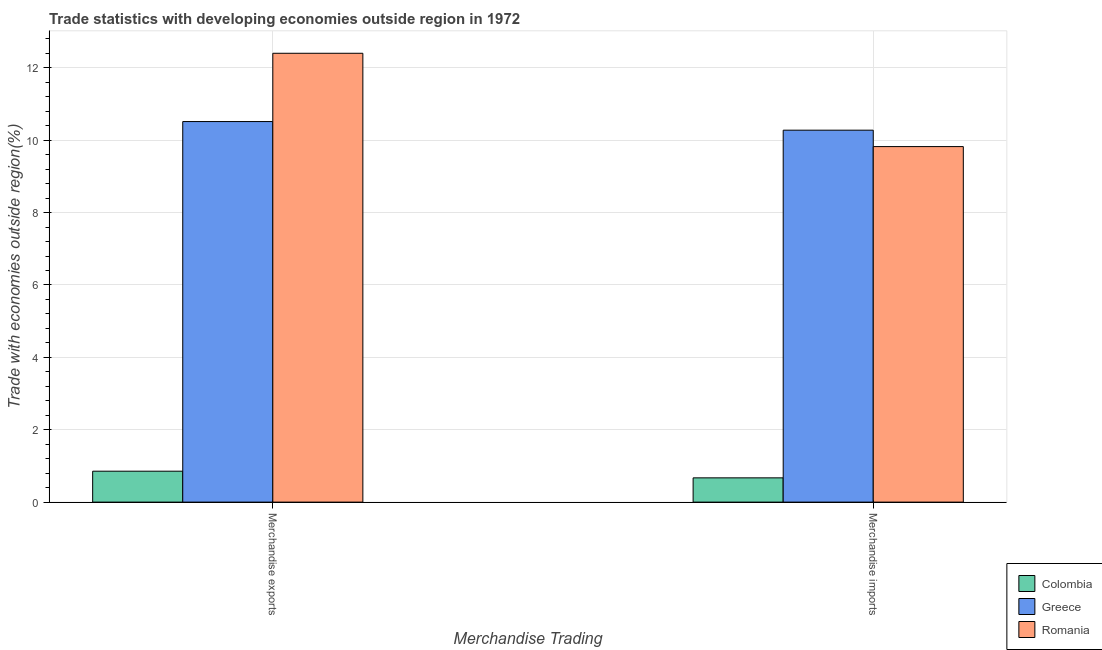Are the number of bars per tick equal to the number of legend labels?
Provide a short and direct response. Yes. How many bars are there on the 1st tick from the left?
Offer a very short reply. 3. How many bars are there on the 2nd tick from the right?
Ensure brevity in your answer.  3. What is the merchandise exports in Greece?
Your answer should be very brief. 10.52. Across all countries, what is the maximum merchandise imports?
Provide a short and direct response. 10.28. Across all countries, what is the minimum merchandise exports?
Provide a short and direct response. 0.85. In which country was the merchandise exports maximum?
Your response must be concise. Romania. What is the total merchandise imports in the graph?
Offer a very short reply. 20.77. What is the difference between the merchandise imports in Romania and that in Colombia?
Keep it short and to the point. 9.15. What is the difference between the merchandise exports in Colombia and the merchandise imports in Greece?
Provide a short and direct response. -9.42. What is the average merchandise imports per country?
Your answer should be compact. 6.92. What is the difference between the merchandise exports and merchandise imports in Greece?
Ensure brevity in your answer.  0.24. In how many countries, is the merchandise exports greater than 11.6 %?
Provide a short and direct response. 1. What is the ratio of the merchandise exports in Colombia to that in Greece?
Provide a succinct answer. 0.08. What does the 2nd bar from the left in Merchandise imports represents?
Offer a terse response. Greece. What does the 1st bar from the right in Merchandise exports represents?
Provide a short and direct response. Romania. How many bars are there?
Your answer should be compact. 6. Are the values on the major ticks of Y-axis written in scientific E-notation?
Keep it short and to the point. No. Where does the legend appear in the graph?
Make the answer very short. Bottom right. How are the legend labels stacked?
Give a very brief answer. Vertical. What is the title of the graph?
Your answer should be compact. Trade statistics with developing economies outside region in 1972. Does "Luxembourg" appear as one of the legend labels in the graph?
Keep it short and to the point. No. What is the label or title of the X-axis?
Ensure brevity in your answer.  Merchandise Trading. What is the label or title of the Y-axis?
Provide a succinct answer. Trade with economies outside region(%). What is the Trade with economies outside region(%) of Colombia in Merchandise exports?
Your response must be concise. 0.85. What is the Trade with economies outside region(%) in Greece in Merchandise exports?
Provide a short and direct response. 10.52. What is the Trade with economies outside region(%) in Romania in Merchandise exports?
Keep it short and to the point. 12.4. What is the Trade with economies outside region(%) in Colombia in Merchandise imports?
Your response must be concise. 0.67. What is the Trade with economies outside region(%) in Greece in Merchandise imports?
Ensure brevity in your answer.  10.28. What is the Trade with economies outside region(%) of Romania in Merchandise imports?
Offer a terse response. 9.82. Across all Merchandise Trading, what is the maximum Trade with economies outside region(%) in Colombia?
Your answer should be very brief. 0.85. Across all Merchandise Trading, what is the maximum Trade with economies outside region(%) of Greece?
Make the answer very short. 10.52. Across all Merchandise Trading, what is the maximum Trade with economies outside region(%) of Romania?
Ensure brevity in your answer.  12.4. Across all Merchandise Trading, what is the minimum Trade with economies outside region(%) of Colombia?
Make the answer very short. 0.67. Across all Merchandise Trading, what is the minimum Trade with economies outside region(%) of Greece?
Keep it short and to the point. 10.28. Across all Merchandise Trading, what is the minimum Trade with economies outside region(%) in Romania?
Your answer should be very brief. 9.82. What is the total Trade with economies outside region(%) in Colombia in the graph?
Ensure brevity in your answer.  1.53. What is the total Trade with economies outside region(%) in Greece in the graph?
Provide a short and direct response. 20.79. What is the total Trade with economies outside region(%) of Romania in the graph?
Offer a terse response. 22.23. What is the difference between the Trade with economies outside region(%) of Colombia in Merchandise exports and that in Merchandise imports?
Your answer should be compact. 0.18. What is the difference between the Trade with economies outside region(%) in Greece in Merchandise exports and that in Merchandise imports?
Your response must be concise. 0.24. What is the difference between the Trade with economies outside region(%) of Romania in Merchandise exports and that in Merchandise imports?
Your response must be concise. 2.58. What is the difference between the Trade with economies outside region(%) in Colombia in Merchandise exports and the Trade with economies outside region(%) in Greece in Merchandise imports?
Give a very brief answer. -9.42. What is the difference between the Trade with economies outside region(%) in Colombia in Merchandise exports and the Trade with economies outside region(%) in Romania in Merchandise imports?
Your answer should be compact. -8.97. What is the difference between the Trade with economies outside region(%) in Greece in Merchandise exports and the Trade with economies outside region(%) in Romania in Merchandise imports?
Provide a succinct answer. 0.69. What is the average Trade with economies outside region(%) of Colombia per Merchandise Trading?
Your response must be concise. 0.76. What is the average Trade with economies outside region(%) in Greece per Merchandise Trading?
Ensure brevity in your answer.  10.4. What is the average Trade with economies outside region(%) in Romania per Merchandise Trading?
Your answer should be very brief. 11.11. What is the difference between the Trade with economies outside region(%) of Colombia and Trade with economies outside region(%) of Greece in Merchandise exports?
Give a very brief answer. -9.66. What is the difference between the Trade with economies outside region(%) of Colombia and Trade with economies outside region(%) of Romania in Merchandise exports?
Provide a short and direct response. -11.55. What is the difference between the Trade with economies outside region(%) of Greece and Trade with economies outside region(%) of Romania in Merchandise exports?
Give a very brief answer. -1.89. What is the difference between the Trade with economies outside region(%) in Colombia and Trade with economies outside region(%) in Greece in Merchandise imports?
Make the answer very short. -9.61. What is the difference between the Trade with economies outside region(%) in Colombia and Trade with economies outside region(%) in Romania in Merchandise imports?
Your answer should be compact. -9.15. What is the difference between the Trade with economies outside region(%) in Greece and Trade with economies outside region(%) in Romania in Merchandise imports?
Your response must be concise. 0.45. What is the ratio of the Trade with economies outside region(%) of Colombia in Merchandise exports to that in Merchandise imports?
Give a very brief answer. 1.27. What is the ratio of the Trade with economies outside region(%) of Greece in Merchandise exports to that in Merchandise imports?
Offer a terse response. 1.02. What is the ratio of the Trade with economies outside region(%) in Romania in Merchandise exports to that in Merchandise imports?
Provide a short and direct response. 1.26. What is the difference between the highest and the second highest Trade with economies outside region(%) of Colombia?
Keep it short and to the point. 0.18. What is the difference between the highest and the second highest Trade with economies outside region(%) of Greece?
Offer a terse response. 0.24. What is the difference between the highest and the second highest Trade with economies outside region(%) of Romania?
Your answer should be very brief. 2.58. What is the difference between the highest and the lowest Trade with economies outside region(%) in Colombia?
Offer a very short reply. 0.18. What is the difference between the highest and the lowest Trade with economies outside region(%) in Greece?
Your answer should be compact. 0.24. What is the difference between the highest and the lowest Trade with economies outside region(%) of Romania?
Make the answer very short. 2.58. 